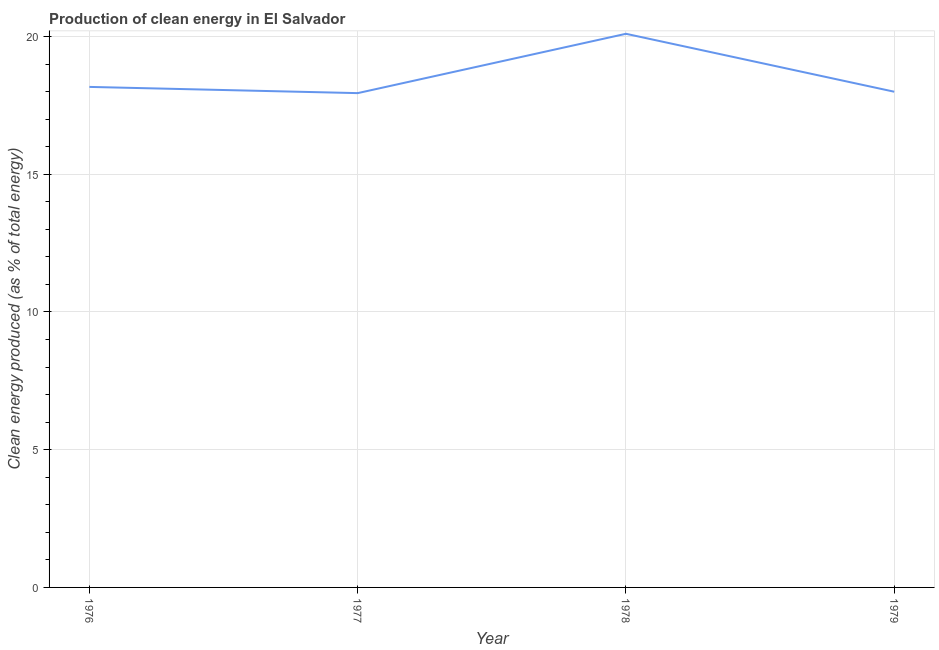What is the production of clean energy in 1976?
Your answer should be very brief. 18.17. Across all years, what is the maximum production of clean energy?
Offer a terse response. 20.1. Across all years, what is the minimum production of clean energy?
Give a very brief answer. 17.94. In which year was the production of clean energy maximum?
Provide a short and direct response. 1978. In which year was the production of clean energy minimum?
Offer a very short reply. 1977. What is the sum of the production of clean energy?
Your answer should be very brief. 74.21. What is the difference between the production of clean energy in 1977 and 1979?
Your answer should be very brief. -0.05. What is the average production of clean energy per year?
Keep it short and to the point. 18.55. What is the median production of clean energy?
Provide a succinct answer. 18.08. Do a majority of the years between 1976 and 1978 (inclusive) have production of clean energy greater than 4 %?
Your response must be concise. Yes. What is the ratio of the production of clean energy in 1976 to that in 1979?
Provide a short and direct response. 1.01. Is the production of clean energy in 1978 less than that in 1979?
Your answer should be very brief. No. Is the difference between the production of clean energy in 1978 and 1979 greater than the difference between any two years?
Ensure brevity in your answer.  No. What is the difference between the highest and the second highest production of clean energy?
Offer a very short reply. 1.93. What is the difference between the highest and the lowest production of clean energy?
Provide a short and direct response. 2.15. In how many years, is the production of clean energy greater than the average production of clean energy taken over all years?
Offer a terse response. 1. How many lines are there?
Ensure brevity in your answer.  1. What is the difference between two consecutive major ticks on the Y-axis?
Offer a terse response. 5. Are the values on the major ticks of Y-axis written in scientific E-notation?
Give a very brief answer. No. Does the graph contain any zero values?
Ensure brevity in your answer.  No. Does the graph contain grids?
Your answer should be compact. Yes. What is the title of the graph?
Offer a very short reply. Production of clean energy in El Salvador. What is the label or title of the X-axis?
Give a very brief answer. Year. What is the label or title of the Y-axis?
Your answer should be very brief. Clean energy produced (as % of total energy). What is the Clean energy produced (as % of total energy) of 1976?
Your answer should be very brief. 18.17. What is the Clean energy produced (as % of total energy) in 1977?
Offer a terse response. 17.94. What is the Clean energy produced (as % of total energy) in 1978?
Your answer should be compact. 20.1. What is the Clean energy produced (as % of total energy) of 1979?
Offer a terse response. 17.99. What is the difference between the Clean energy produced (as % of total energy) in 1976 and 1977?
Provide a short and direct response. 0.23. What is the difference between the Clean energy produced (as % of total energy) in 1976 and 1978?
Your answer should be very brief. -1.93. What is the difference between the Clean energy produced (as % of total energy) in 1976 and 1979?
Make the answer very short. 0.18. What is the difference between the Clean energy produced (as % of total energy) in 1977 and 1978?
Offer a terse response. -2.15. What is the difference between the Clean energy produced (as % of total energy) in 1977 and 1979?
Make the answer very short. -0.05. What is the difference between the Clean energy produced (as % of total energy) in 1978 and 1979?
Keep it short and to the point. 2.1. What is the ratio of the Clean energy produced (as % of total energy) in 1976 to that in 1978?
Your answer should be compact. 0.9. What is the ratio of the Clean energy produced (as % of total energy) in 1976 to that in 1979?
Offer a very short reply. 1.01. What is the ratio of the Clean energy produced (as % of total energy) in 1977 to that in 1978?
Provide a short and direct response. 0.89. What is the ratio of the Clean energy produced (as % of total energy) in 1977 to that in 1979?
Make the answer very short. 1. What is the ratio of the Clean energy produced (as % of total energy) in 1978 to that in 1979?
Provide a short and direct response. 1.12. 